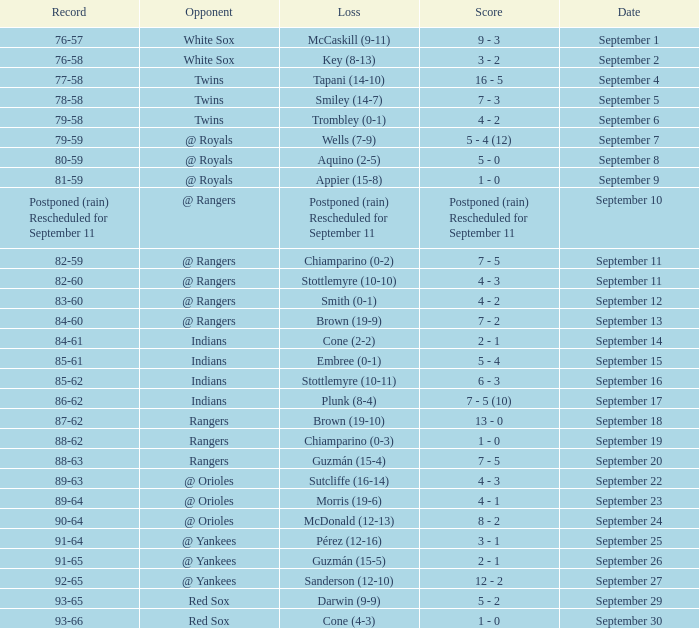What opponent has a record of 86-62? Indians. 